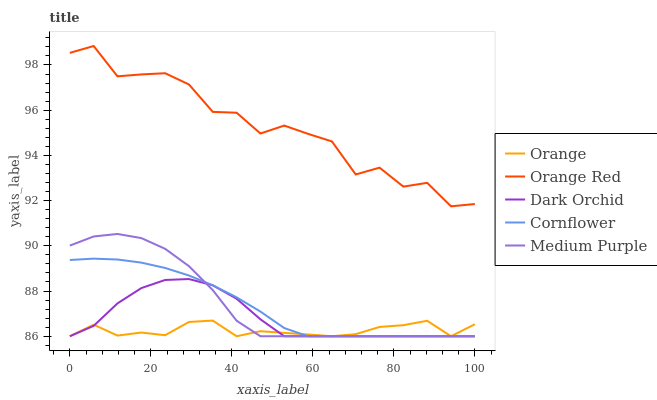Does Orange have the minimum area under the curve?
Answer yes or no. Yes. Does Orange Red have the maximum area under the curve?
Answer yes or no. Yes. Does Cornflower have the minimum area under the curve?
Answer yes or no. No. Does Cornflower have the maximum area under the curve?
Answer yes or no. No. Is Cornflower the smoothest?
Answer yes or no. Yes. Is Orange Red the roughest?
Answer yes or no. Yes. Is Medium Purple the smoothest?
Answer yes or no. No. Is Medium Purple the roughest?
Answer yes or no. No. Does Orange Red have the lowest value?
Answer yes or no. No. Does Orange Red have the highest value?
Answer yes or no. Yes. Does Cornflower have the highest value?
Answer yes or no. No. Is Cornflower less than Orange Red?
Answer yes or no. Yes. Is Orange Red greater than Dark Orchid?
Answer yes or no. Yes. Does Cornflower intersect Medium Purple?
Answer yes or no. Yes. Is Cornflower less than Medium Purple?
Answer yes or no. No. Is Cornflower greater than Medium Purple?
Answer yes or no. No. Does Cornflower intersect Orange Red?
Answer yes or no. No. 